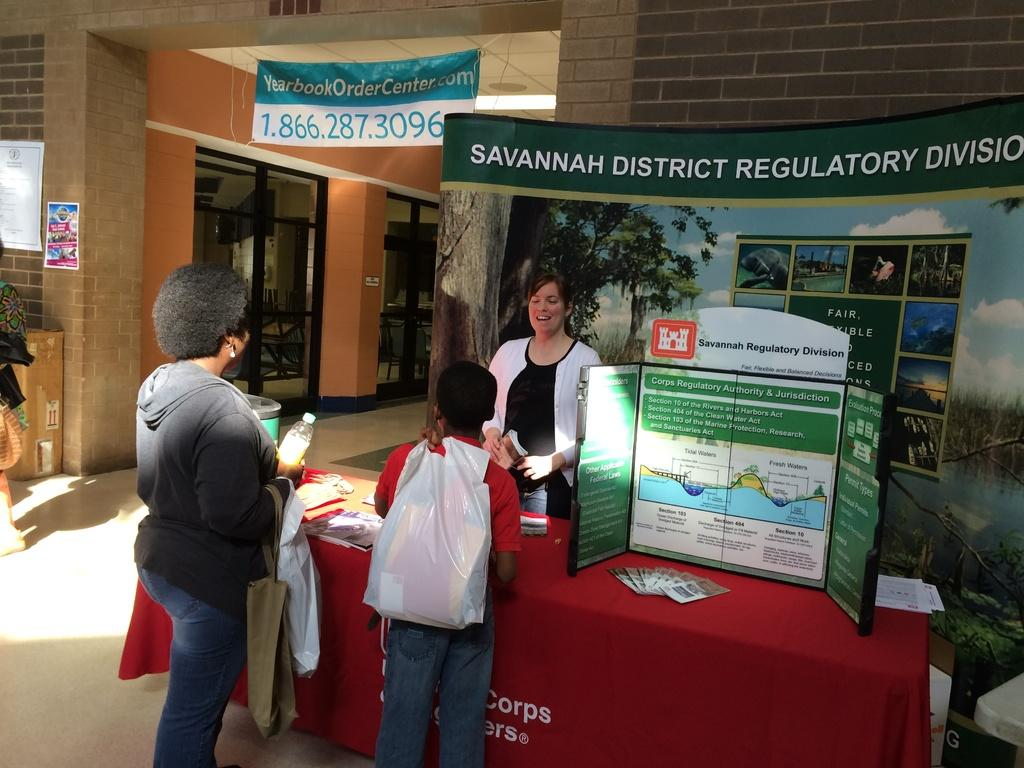What is happening on the ground in the image? There are people on the ground in the image. What is present on the ground along with the people? There is a table in the image. What can be seen hanging or displayed in the image? There is a banner and posters in the image. What else is visible in the image besides the people and objects? There is a building in the background of the image. What type of brass instrument is being played by the people in the image? There is no brass instrument present in the image; it only shows people, a table, a banner, posters, objects, and a building in the background. What time of day is it in the image, given the presence of morning light? The time of day is not mentioned or indicated in the image, so it cannot be determined whether it is morning or not. 